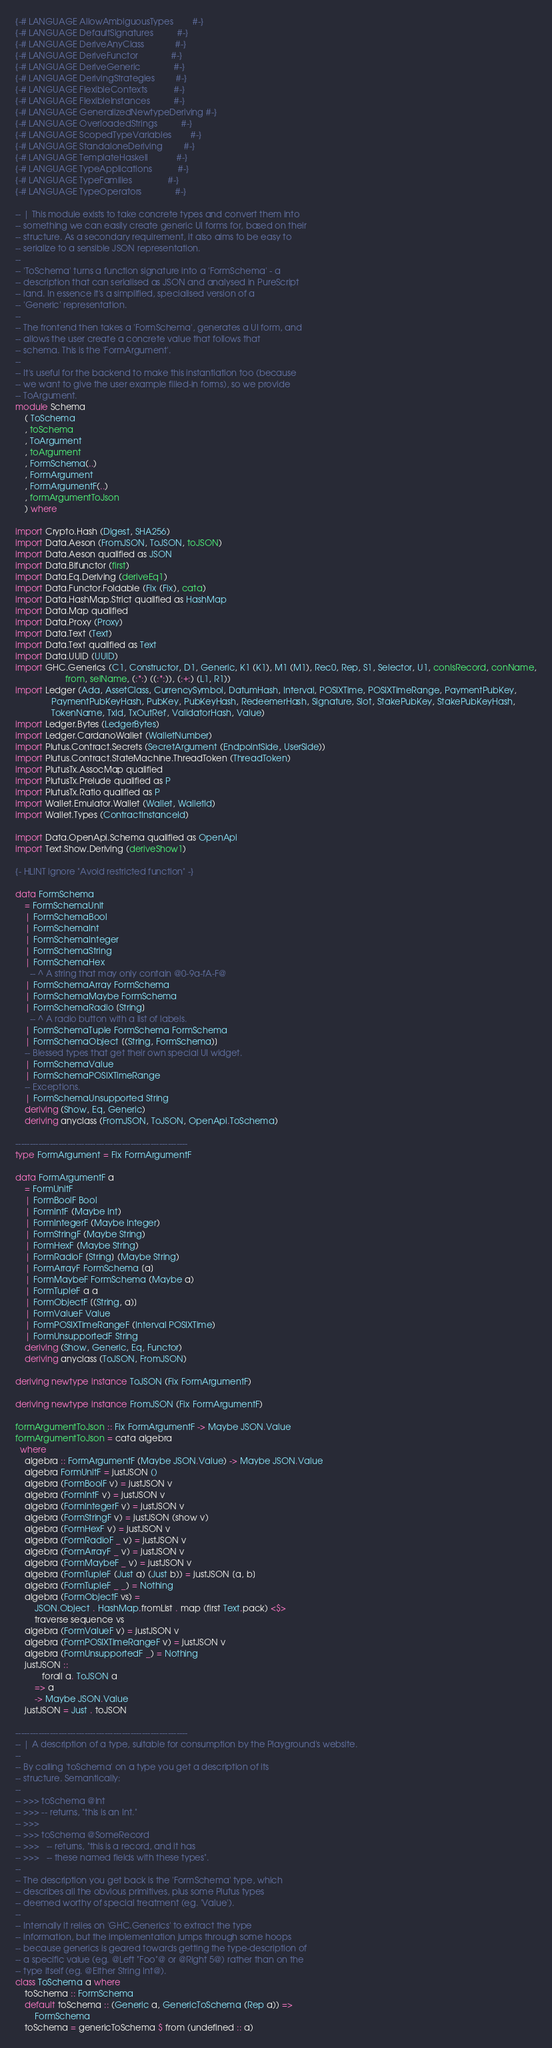<code> <loc_0><loc_0><loc_500><loc_500><_Haskell_>{-# LANGUAGE AllowAmbiguousTypes        #-}
{-# LANGUAGE DefaultSignatures          #-}
{-# LANGUAGE DeriveAnyClass             #-}
{-# LANGUAGE DeriveFunctor              #-}
{-# LANGUAGE DeriveGeneric              #-}
{-# LANGUAGE DerivingStrategies         #-}
{-# LANGUAGE FlexibleContexts           #-}
{-# LANGUAGE FlexibleInstances          #-}
{-# LANGUAGE GeneralizedNewtypeDeriving #-}
{-# LANGUAGE OverloadedStrings          #-}
{-# LANGUAGE ScopedTypeVariables        #-}
{-# LANGUAGE StandaloneDeriving         #-}
{-# LANGUAGE TemplateHaskell            #-}
{-# LANGUAGE TypeApplications           #-}
{-# LANGUAGE TypeFamilies               #-}
{-# LANGUAGE TypeOperators              #-}

-- | This module exists to take concrete types and convert them into
-- something we can easily create generic UI forms for, based on their
-- structure. As a secondary requirement, it also aims to be easy to
-- serialize to a sensible JSON representation.
--
-- 'ToSchema' turns a function signature into a 'FormSchema' - a
-- description that can serialised as JSON and analysed in PureScript
-- land. In essence it's a simplified, specialised version of a
-- 'Generic' representation.
--
-- The frontend then takes a 'FormSchema', generates a UI form, and
-- allows the user create a concrete value that follows that
-- schema. This is the 'FormArgument'.
--
-- It's useful for the backend to make this instantiation too (because
-- we want to give the user example filled-in forms), so we provide
-- ToArgument.
module Schema
    ( ToSchema
    , toSchema
    , ToArgument
    , toArgument
    , FormSchema(..)
    , FormArgument
    , FormArgumentF(..)
    , formArgumentToJson
    ) where

import Crypto.Hash (Digest, SHA256)
import Data.Aeson (FromJSON, ToJSON, toJSON)
import Data.Aeson qualified as JSON
import Data.Bifunctor (first)
import Data.Eq.Deriving (deriveEq1)
import Data.Functor.Foldable (Fix (Fix), cata)
import Data.HashMap.Strict qualified as HashMap
import Data.Map qualified
import Data.Proxy (Proxy)
import Data.Text (Text)
import Data.Text qualified as Text
import Data.UUID (UUID)
import GHC.Generics (C1, Constructor, D1, Generic, K1 (K1), M1 (M1), Rec0, Rep, S1, Selector, U1, conIsRecord, conName,
                     from, selName, (:*:) ((:*:)), (:+:) (L1, R1))
import Ledger (Ada, AssetClass, CurrencySymbol, DatumHash, Interval, POSIXTime, POSIXTimeRange, PaymentPubKey,
               PaymentPubKeyHash, PubKey, PubKeyHash, RedeemerHash, Signature, Slot, StakePubKey, StakePubKeyHash,
               TokenName, TxId, TxOutRef, ValidatorHash, Value)
import Ledger.Bytes (LedgerBytes)
import Ledger.CardanoWallet (WalletNumber)
import Plutus.Contract.Secrets (SecretArgument (EndpointSide, UserSide))
import Plutus.Contract.StateMachine.ThreadToken (ThreadToken)
import PlutusTx.AssocMap qualified
import PlutusTx.Prelude qualified as P
import PlutusTx.Ratio qualified as P
import Wallet.Emulator.Wallet (Wallet, WalletId)
import Wallet.Types (ContractInstanceId)

import Data.OpenApi.Schema qualified as OpenApi
import Text.Show.Deriving (deriveShow1)

{- HLINT ignore "Avoid restricted function" -}

data FormSchema
    = FormSchemaUnit
    | FormSchemaBool
    | FormSchemaInt
    | FormSchemaInteger
    | FormSchemaString
    | FormSchemaHex
      -- ^ A string that may only contain @0-9a-fA-F@
    | FormSchemaArray FormSchema
    | FormSchemaMaybe FormSchema
    | FormSchemaRadio [String]
      -- ^ A radio button with a list of labels.
    | FormSchemaTuple FormSchema FormSchema
    | FormSchemaObject [(String, FormSchema)]
    -- Blessed types that get their own special UI widget.
    | FormSchemaValue
    | FormSchemaPOSIXTimeRange
    -- Exceptions.
    | FormSchemaUnsupported String
    deriving (Show, Eq, Generic)
    deriving anyclass (FromJSON, ToJSON, OpenApi.ToSchema)

------------------------------------------------------------
type FormArgument = Fix FormArgumentF

data FormArgumentF a
    = FormUnitF
    | FormBoolF Bool
    | FormIntF (Maybe Int)
    | FormIntegerF (Maybe Integer)
    | FormStringF (Maybe String)
    | FormHexF (Maybe String)
    | FormRadioF [String] (Maybe String)
    | FormArrayF FormSchema [a]
    | FormMaybeF FormSchema (Maybe a)
    | FormTupleF a a
    | FormObjectF [(String, a)]
    | FormValueF Value
    | FormPOSIXTimeRangeF (Interval POSIXTime)
    | FormUnsupportedF String
    deriving (Show, Generic, Eq, Functor)
    deriving anyclass (ToJSON, FromJSON)

deriving newtype instance ToJSON (Fix FormArgumentF)

deriving newtype instance FromJSON (Fix FormArgumentF)

formArgumentToJson :: Fix FormArgumentF -> Maybe JSON.Value
formArgumentToJson = cata algebra
  where
    algebra :: FormArgumentF (Maybe JSON.Value) -> Maybe JSON.Value
    algebra FormUnitF = justJSON ()
    algebra (FormBoolF v) = justJSON v
    algebra (FormIntF v) = justJSON v
    algebra (FormIntegerF v) = justJSON v
    algebra (FormStringF v) = justJSON (show v)
    algebra (FormHexF v) = justJSON v
    algebra (FormRadioF _ v) = justJSON v
    algebra (FormArrayF _ v) = justJSON v
    algebra (FormMaybeF _ v) = justJSON v
    algebra (FormTupleF (Just a) (Just b)) = justJSON [a, b]
    algebra (FormTupleF _ _) = Nothing
    algebra (FormObjectF vs) =
        JSON.Object . HashMap.fromList . map (first Text.pack) <$>
        traverse sequence vs
    algebra (FormValueF v) = justJSON v
    algebra (FormPOSIXTimeRangeF v) = justJSON v
    algebra (FormUnsupportedF _) = Nothing
    justJSON ::
           forall a. ToJSON a
        => a
        -> Maybe JSON.Value
    justJSON = Just . toJSON

------------------------------------------------------------
-- | A description of a type, suitable for consumption by the Playground's website.
--
-- By calling 'toSchema' on a type you get a description of its
-- structure. Semantically:
--
-- >>> toSchema @Int
-- >>> -- returns, "this is an Int."
-- >>>
-- >>> toSchema @SomeRecord
-- >>>   -- returns, "this is a record, and it has
-- >>>   -- these named fields with these types".
--
-- The description you get back is the 'FormSchema' type, which
-- describes all the obvious primitives, plus some Plutus types
-- deemed worthy of special treatment (eg. 'Value').
--
-- Internally it relies on 'GHC.Generics' to extract the type
-- information, but the implementation jumps through some hoops
-- because generics is geared towards getting the type-description of
-- a specific value (eg. @Left "Foo"@ or @Right 5@) rather than on the
-- type itself (eg. @Either String Int@).
class ToSchema a where
    toSchema :: FormSchema
    default toSchema :: (Generic a, GenericToSchema (Rep a)) =>
        FormSchema
    toSchema = genericToSchema $ from (undefined :: a)
</code> 